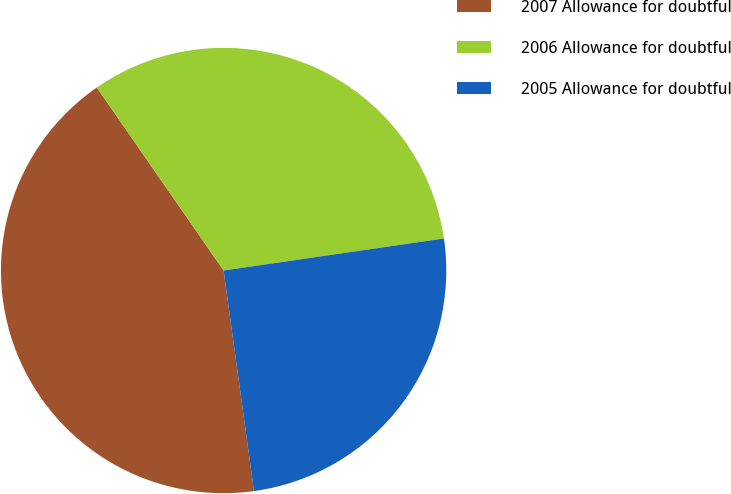Convert chart to OTSL. <chart><loc_0><loc_0><loc_500><loc_500><pie_chart><fcel>2007 Allowance for doubtful<fcel>2006 Allowance for doubtful<fcel>2005 Allowance for doubtful<nl><fcel>42.54%<fcel>32.35%<fcel>25.12%<nl></chart> 